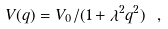<formula> <loc_0><loc_0><loc_500><loc_500>V ( q ) = V _ { 0 } / ( 1 + \lambda ^ { 2 } q ^ { 2 } ) \ ,</formula> 